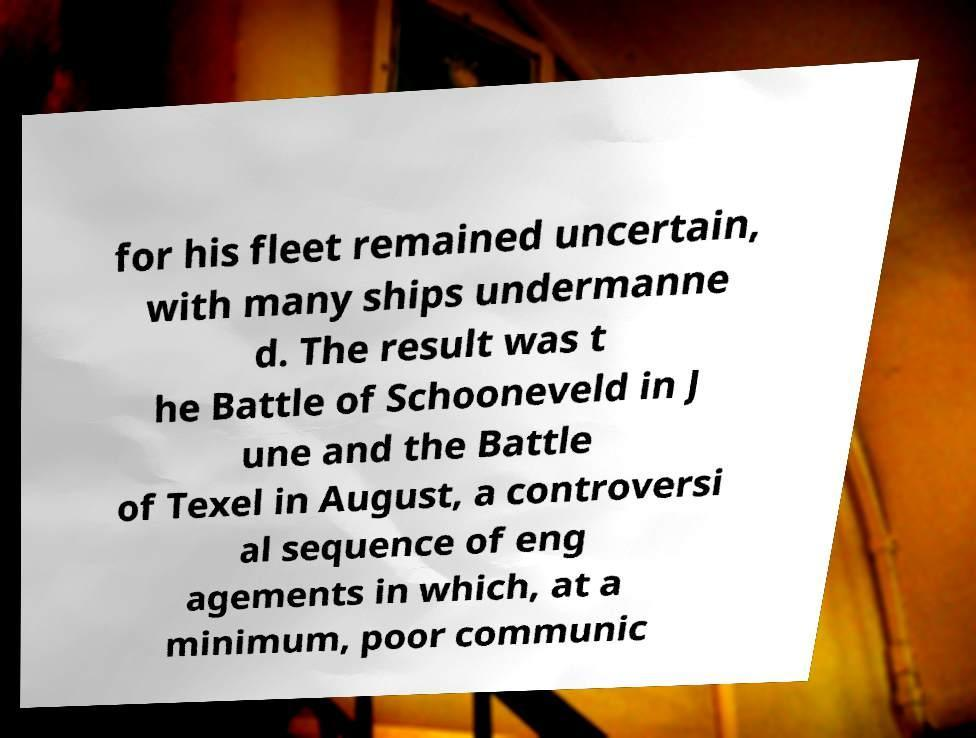Please identify and transcribe the text found in this image. for his fleet remained uncertain, with many ships undermanne d. The result was t he Battle of Schooneveld in J une and the Battle of Texel in August, a controversi al sequence of eng agements in which, at a minimum, poor communic 